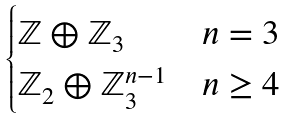Convert formula to latex. <formula><loc_0><loc_0><loc_500><loc_500>\begin{cases} \mathbb { Z } \oplus \mathbb { Z } _ { 3 } & n = 3 \\ \mathbb { Z } _ { 2 } \oplus \mathbb { Z } ^ { n - 1 } _ { 3 } & n \geq 4 \\ \end{cases}</formula> 